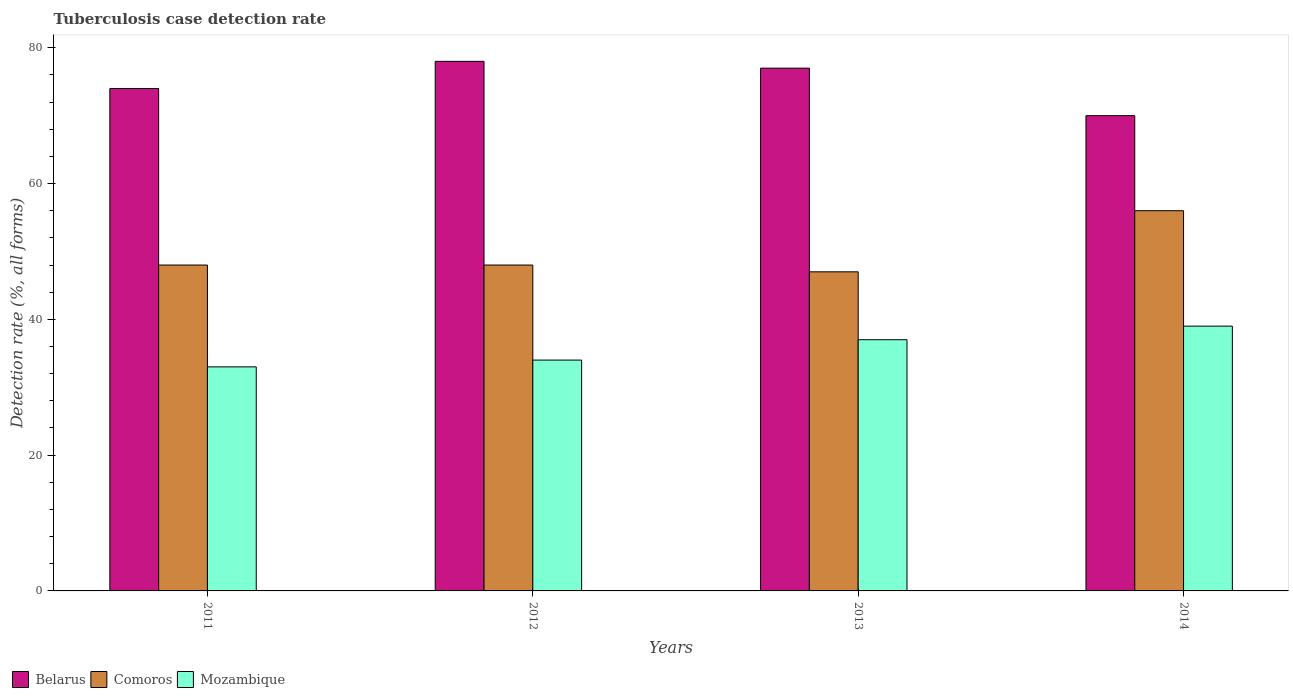How many groups of bars are there?
Provide a succinct answer. 4. Are the number of bars on each tick of the X-axis equal?
Offer a terse response. Yes. How many bars are there on the 2nd tick from the left?
Your response must be concise. 3. How many bars are there on the 1st tick from the right?
Make the answer very short. 3. What is the label of the 3rd group of bars from the left?
Your answer should be compact. 2013. In how many cases, is the number of bars for a given year not equal to the number of legend labels?
Your response must be concise. 0. What is the tuberculosis case detection rate in in Mozambique in 2013?
Your answer should be compact. 37. Across all years, what is the maximum tuberculosis case detection rate in in Belarus?
Offer a very short reply. 78. Across all years, what is the minimum tuberculosis case detection rate in in Mozambique?
Ensure brevity in your answer.  33. In which year was the tuberculosis case detection rate in in Belarus maximum?
Keep it short and to the point. 2012. In which year was the tuberculosis case detection rate in in Mozambique minimum?
Keep it short and to the point. 2011. What is the total tuberculosis case detection rate in in Belarus in the graph?
Make the answer very short. 299. What is the difference between the tuberculosis case detection rate in in Belarus in 2011 and that in 2012?
Give a very brief answer. -4. What is the average tuberculosis case detection rate in in Mozambique per year?
Your answer should be very brief. 35.75. In the year 2014, what is the difference between the tuberculosis case detection rate in in Belarus and tuberculosis case detection rate in in Mozambique?
Make the answer very short. 31. What is the ratio of the tuberculosis case detection rate in in Mozambique in 2011 to that in 2014?
Offer a very short reply. 0.85. Is the tuberculosis case detection rate in in Mozambique in 2012 less than that in 2013?
Ensure brevity in your answer.  Yes. What is the difference between the highest and the second highest tuberculosis case detection rate in in Mozambique?
Give a very brief answer. 2. What does the 1st bar from the left in 2014 represents?
Ensure brevity in your answer.  Belarus. What does the 1st bar from the right in 2014 represents?
Provide a succinct answer. Mozambique. How many bars are there?
Your answer should be very brief. 12. Are all the bars in the graph horizontal?
Provide a short and direct response. No. What is the difference between two consecutive major ticks on the Y-axis?
Offer a terse response. 20. Does the graph contain grids?
Your response must be concise. No. Where does the legend appear in the graph?
Your answer should be very brief. Bottom left. How many legend labels are there?
Make the answer very short. 3. What is the title of the graph?
Provide a succinct answer. Tuberculosis case detection rate. Does "Latin America(developing only)" appear as one of the legend labels in the graph?
Offer a very short reply. No. What is the label or title of the X-axis?
Keep it short and to the point. Years. What is the label or title of the Y-axis?
Your answer should be compact. Detection rate (%, all forms). What is the Detection rate (%, all forms) of Belarus in 2012?
Your answer should be very brief. 78. What is the Detection rate (%, all forms) in Belarus in 2013?
Your answer should be very brief. 77. What is the Detection rate (%, all forms) of Comoros in 2013?
Make the answer very short. 47. What is the Detection rate (%, all forms) of Belarus in 2014?
Offer a very short reply. 70. What is the Detection rate (%, all forms) of Mozambique in 2014?
Keep it short and to the point. 39. Across all years, what is the maximum Detection rate (%, all forms) of Comoros?
Keep it short and to the point. 56. Across all years, what is the maximum Detection rate (%, all forms) in Mozambique?
Make the answer very short. 39. What is the total Detection rate (%, all forms) in Belarus in the graph?
Your answer should be compact. 299. What is the total Detection rate (%, all forms) of Comoros in the graph?
Give a very brief answer. 199. What is the total Detection rate (%, all forms) in Mozambique in the graph?
Give a very brief answer. 143. What is the difference between the Detection rate (%, all forms) in Belarus in 2011 and that in 2012?
Keep it short and to the point. -4. What is the difference between the Detection rate (%, all forms) of Belarus in 2011 and that in 2013?
Offer a very short reply. -3. What is the difference between the Detection rate (%, all forms) of Comoros in 2011 and that in 2013?
Your response must be concise. 1. What is the difference between the Detection rate (%, all forms) in Mozambique in 2011 and that in 2013?
Make the answer very short. -4. What is the difference between the Detection rate (%, all forms) of Belarus in 2011 and that in 2014?
Offer a terse response. 4. What is the difference between the Detection rate (%, all forms) in Mozambique in 2011 and that in 2014?
Make the answer very short. -6. What is the difference between the Detection rate (%, all forms) of Comoros in 2012 and that in 2013?
Make the answer very short. 1. What is the difference between the Detection rate (%, all forms) of Comoros in 2012 and that in 2014?
Ensure brevity in your answer.  -8. What is the difference between the Detection rate (%, all forms) of Mozambique in 2012 and that in 2014?
Provide a short and direct response. -5. What is the difference between the Detection rate (%, all forms) of Belarus in 2013 and that in 2014?
Provide a succinct answer. 7. What is the difference between the Detection rate (%, all forms) of Mozambique in 2013 and that in 2014?
Provide a short and direct response. -2. What is the difference between the Detection rate (%, all forms) in Belarus in 2011 and the Detection rate (%, all forms) in Mozambique in 2012?
Your answer should be compact. 40. What is the difference between the Detection rate (%, all forms) in Comoros in 2011 and the Detection rate (%, all forms) in Mozambique in 2012?
Your response must be concise. 14. What is the difference between the Detection rate (%, all forms) in Belarus in 2011 and the Detection rate (%, all forms) in Mozambique in 2013?
Ensure brevity in your answer.  37. What is the difference between the Detection rate (%, all forms) of Comoros in 2011 and the Detection rate (%, all forms) of Mozambique in 2013?
Your answer should be very brief. 11. What is the difference between the Detection rate (%, all forms) in Belarus in 2011 and the Detection rate (%, all forms) in Comoros in 2014?
Offer a terse response. 18. What is the difference between the Detection rate (%, all forms) in Belarus in 2011 and the Detection rate (%, all forms) in Mozambique in 2014?
Your response must be concise. 35. What is the difference between the Detection rate (%, all forms) in Belarus in 2012 and the Detection rate (%, all forms) in Mozambique in 2013?
Your response must be concise. 41. What is the difference between the Detection rate (%, all forms) in Comoros in 2012 and the Detection rate (%, all forms) in Mozambique in 2013?
Your response must be concise. 11. What is the difference between the Detection rate (%, all forms) of Comoros in 2012 and the Detection rate (%, all forms) of Mozambique in 2014?
Your answer should be compact. 9. What is the difference between the Detection rate (%, all forms) of Belarus in 2013 and the Detection rate (%, all forms) of Mozambique in 2014?
Ensure brevity in your answer.  38. What is the difference between the Detection rate (%, all forms) in Comoros in 2013 and the Detection rate (%, all forms) in Mozambique in 2014?
Your response must be concise. 8. What is the average Detection rate (%, all forms) in Belarus per year?
Your answer should be very brief. 74.75. What is the average Detection rate (%, all forms) in Comoros per year?
Offer a terse response. 49.75. What is the average Detection rate (%, all forms) in Mozambique per year?
Offer a terse response. 35.75. In the year 2011, what is the difference between the Detection rate (%, all forms) in Belarus and Detection rate (%, all forms) in Comoros?
Provide a succinct answer. 26. In the year 2012, what is the difference between the Detection rate (%, all forms) in Belarus and Detection rate (%, all forms) in Mozambique?
Provide a succinct answer. 44. In the year 2012, what is the difference between the Detection rate (%, all forms) of Comoros and Detection rate (%, all forms) of Mozambique?
Make the answer very short. 14. In the year 2014, what is the difference between the Detection rate (%, all forms) in Belarus and Detection rate (%, all forms) in Comoros?
Make the answer very short. 14. In the year 2014, what is the difference between the Detection rate (%, all forms) of Belarus and Detection rate (%, all forms) of Mozambique?
Your answer should be very brief. 31. In the year 2014, what is the difference between the Detection rate (%, all forms) in Comoros and Detection rate (%, all forms) in Mozambique?
Offer a very short reply. 17. What is the ratio of the Detection rate (%, all forms) in Belarus in 2011 to that in 2012?
Provide a succinct answer. 0.95. What is the ratio of the Detection rate (%, all forms) of Mozambique in 2011 to that in 2012?
Offer a very short reply. 0.97. What is the ratio of the Detection rate (%, all forms) of Belarus in 2011 to that in 2013?
Provide a short and direct response. 0.96. What is the ratio of the Detection rate (%, all forms) of Comoros in 2011 to that in 2013?
Make the answer very short. 1.02. What is the ratio of the Detection rate (%, all forms) of Mozambique in 2011 to that in 2013?
Make the answer very short. 0.89. What is the ratio of the Detection rate (%, all forms) of Belarus in 2011 to that in 2014?
Offer a very short reply. 1.06. What is the ratio of the Detection rate (%, all forms) in Comoros in 2011 to that in 2014?
Offer a very short reply. 0.86. What is the ratio of the Detection rate (%, all forms) of Mozambique in 2011 to that in 2014?
Provide a short and direct response. 0.85. What is the ratio of the Detection rate (%, all forms) of Comoros in 2012 to that in 2013?
Your answer should be compact. 1.02. What is the ratio of the Detection rate (%, all forms) of Mozambique in 2012 to that in 2013?
Offer a very short reply. 0.92. What is the ratio of the Detection rate (%, all forms) of Belarus in 2012 to that in 2014?
Make the answer very short. 1.11. What is the ratio of the Detection rate (%, all forms) in Comoros in 2012 to that in 2014?
Ensure brevity in your answer.  0.86. What is the ratio of the Detection rate (%, all forms) in Mozambique in 2012 to that in 2014?
Keep it short and to the point. 0.87. What is the ratio of the Detection rate (%, all forms) of Belarus in 2013 to that in 2014?
Provide a short and direct response. 1.1. What is the ratio of the Detection rate (%, all forms) of Comoros in 2013 to that in 2014?
Give a very brief answer. 0.84. What is the ratio of the Detection rate (%, all forms) in Mozambique in 2013 to that in 2014?
Your response must be concise. 0.95. What is the difference between the highest and the second highest Detection rate (%, all forms) of Comoros?
Your answer should be very brief. 8. What is the difference between the highest and the lowest Detection rate (%, all forms) in Belarus?
Make the answer very short. 8. What is the difference between the highest and the lowest Detection rate (%, all forms) in Comoros?
Offer a very short reply. 9. 